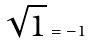Convert formula to latex. <formula><loc_0><loc_0><loc_500><loc_500>\sqrt { 1 } = - 1</formula> 